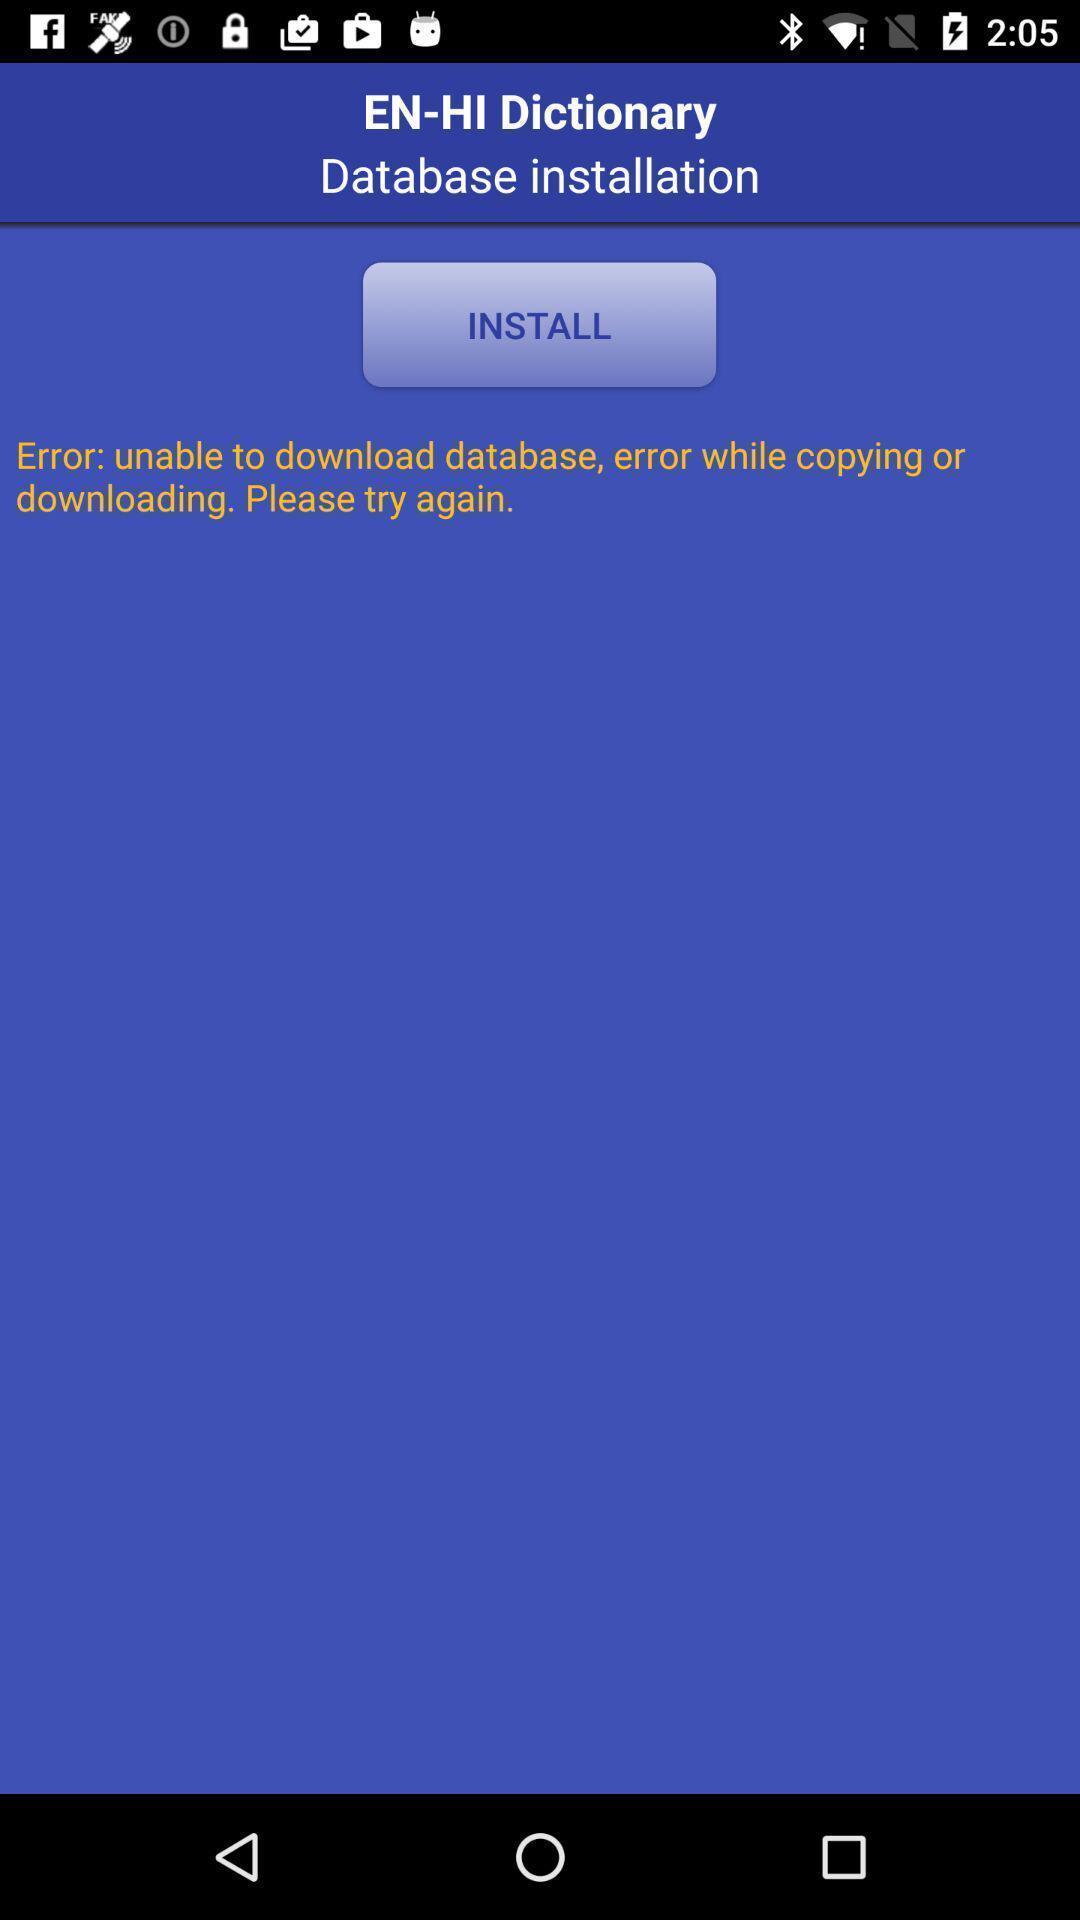What can you discern from this picture? Social app showing for database installation. 